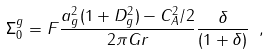Convert formula to latex. <formula><loc_0><loc_0><loc_500><loc_500>\Sigma _ { 0 } ^ { g } = F \frac { a _ { g } ^ { 2 } ( 1 + D _ { g } ^ { 2 } ) - C _ { A } ^ { 2 } / 2 } { 2 \pi G r } \frac { \delta } { ( 1 + \delta ) } \ ,</formula> 